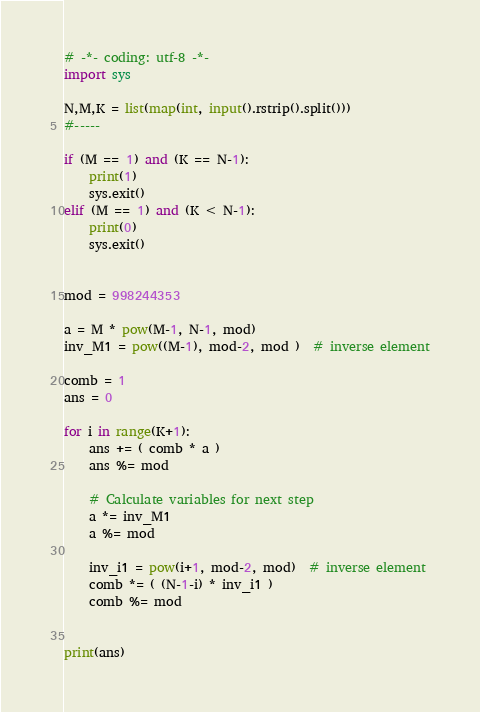Convert code to text. <code><loc_0><loc_0><loc_500><loc_500><_Python_># -*- coding: utf-8 -*-
import sys

N,M,K = list(map(int, input().rstrip().split()))
#-----

if (M == 1) and (K == N-1):
    print(1)
    sys.exit()
elif (M == 1) and (K < N-1):
    print(0)
    sys.exit()


mod = 998244353

a = M * pow(M-1, N-1, mod)
inv_M1 = pow((M-1), mod-2, mod )  # inverse element

comb = 1
ans = 0

for i in range(K+1):
    ans += ( comb * a )
    ans %= mod
    
    # Calculate variables for next step
    a *= inv_M1
    a %= mod
    
    inv_i1 = pow(i+1, mod-2, mod)  # inverse element
    comb *= ( (N-1-i) * inv_i1 )
    comb %= mod


print(ans)
</code> 